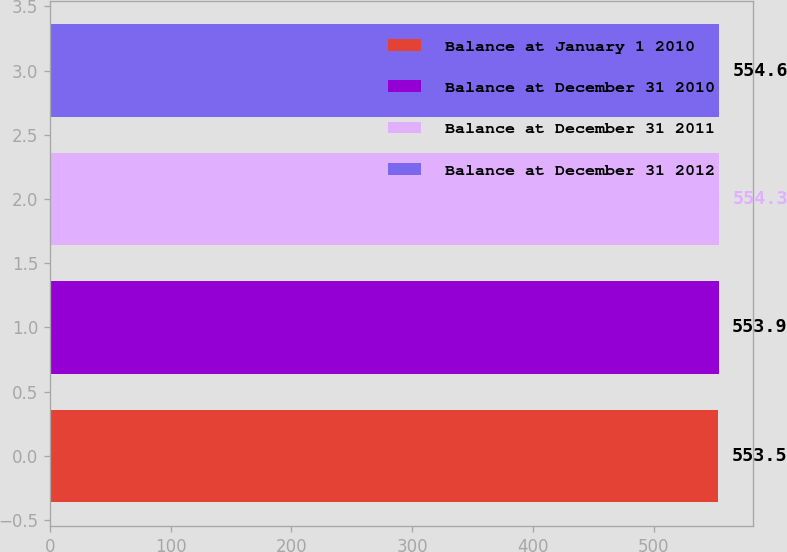<chart> <loc_0><loc_0><loc_500><loc_500><bar_chart><fcel>Balance at January 1 2010<fcel>Balance at December 31 2010<fcel>Balance at December 31 2011<fcel>Balance at December 31 2012<nl><fcel>553.5<fcel>553.9<fcel>554.3<fcel>554.6<nl></chart> 